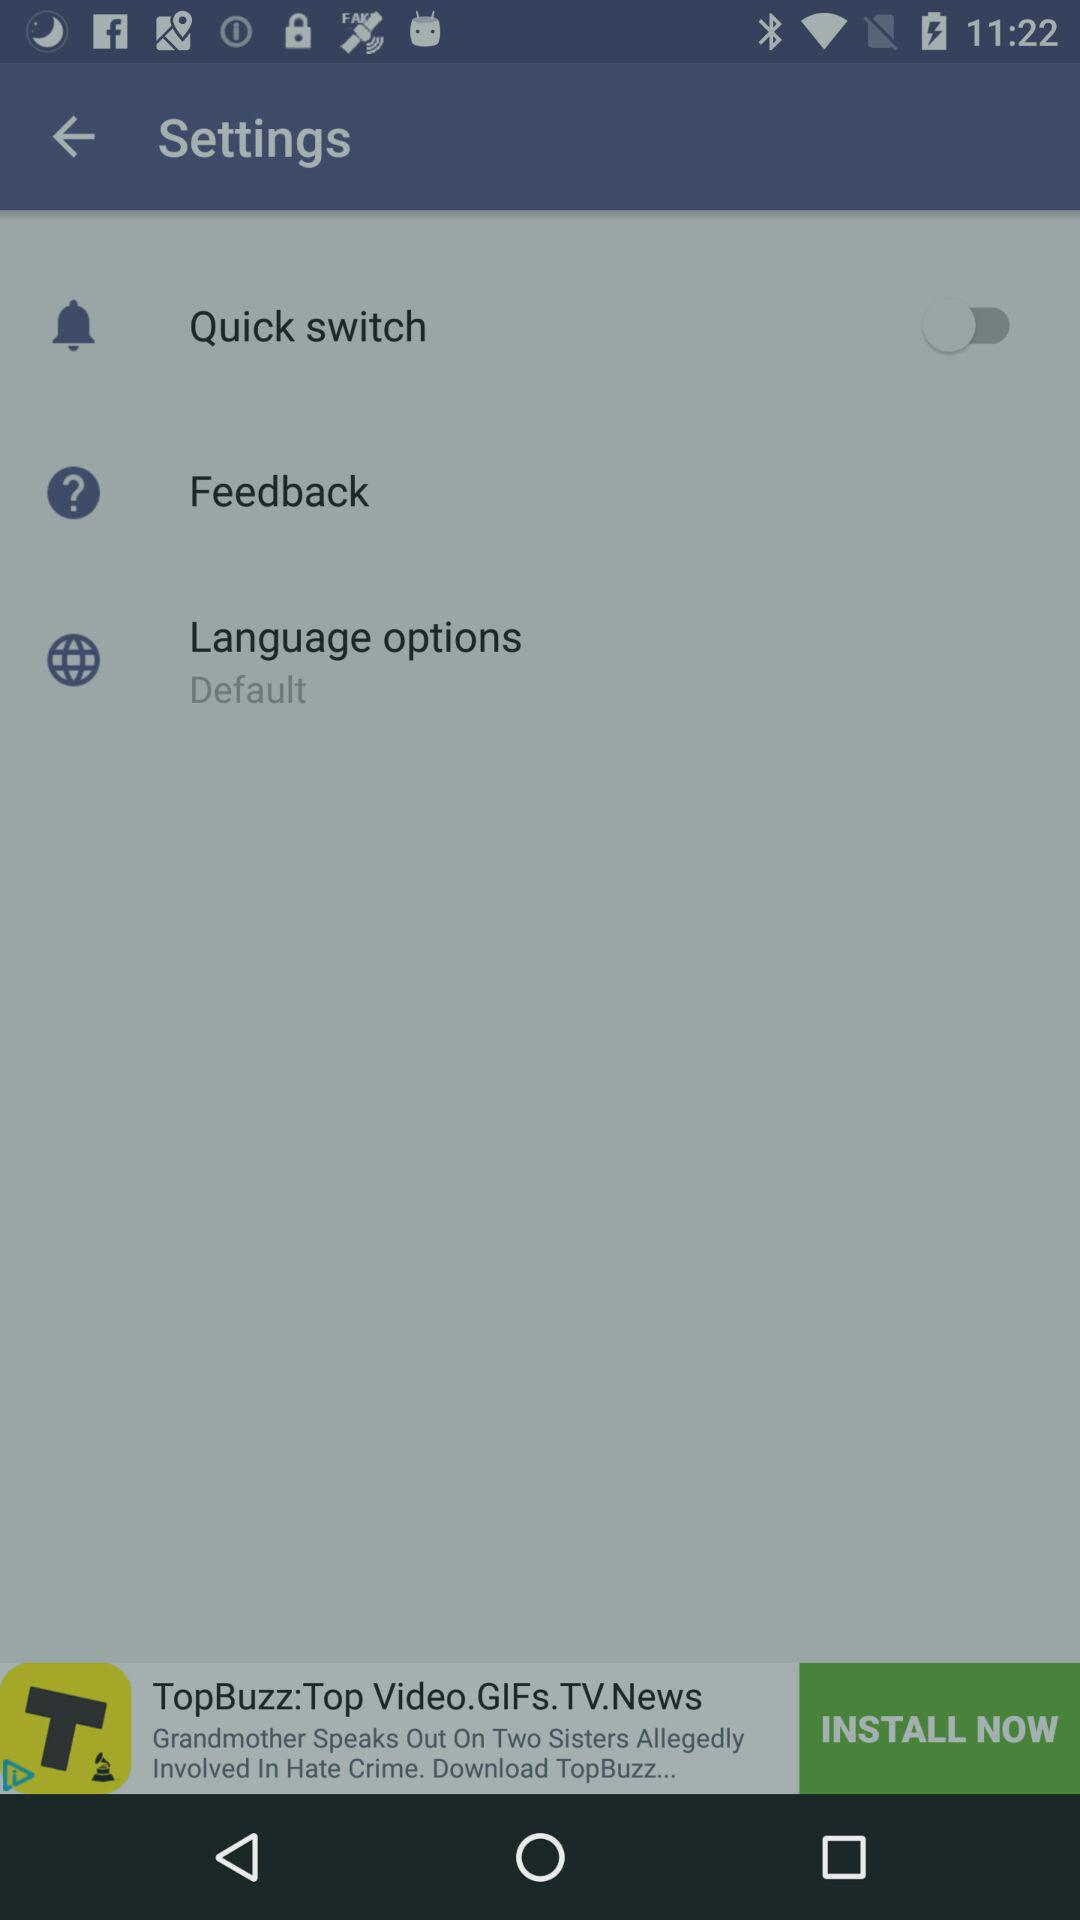What is the status of the "Quick switch"? The status is "off". 